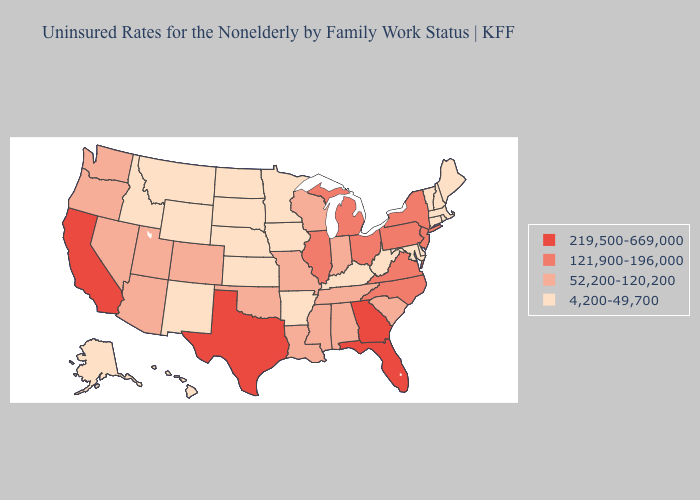Among the states that border Indiana , does Ohio have the highest value?
Give a very brief answer. Yes. Name the states that have a value in the range 4,200-49,700?
Concise answer only. Alaska, Arkansas, Connecticut, Delaware, Hawaii, Idaho, Iowa, Kansas, Kentucky, Maine, Maryland, Massachusetts, Minnesota, Montana, Nebraska, New Hampshire, New Mexico, North Dakota, Rhode Island, South Dakota, Vermont, West Virginia, Wyoming. Does Mississippi have the highest value in the South?
Be succinct. No. Which states have the lowest value in the South?
Answer briefly. Arkansas, Delaware, Kentucky, Maryland, West Virginia. Which states have the lowest value in the USA?
Short answer required. Alaska, Arkansas, Connecticut, Delaware, Hawaii, Idaho, Iowa, Kansas, Kentucky, Maine, Maryland, Massachusetts, Minnesota, Montana, Nebraska, New Hampshire, New Mexico, North Dakota, Rhode Island, South Dakota, Vermont, West Virginia, Wyoming. What is the value of Ohio?
Give a very brief answer. 121,900-196,000. What is the value of Washington?
Give a very brief answer. 52,200-120,200. Does the map have missing data?
Give a very brief answer. No. Name the states that have a value in the range 219,500-669,000?
Answer briefly. California, Florida, Georgia, Texas. What is the value of South Dakota?
Short answer required. 4,200-49,700. Does Maryland have the lowest value in the South?
Concise answer only. Yes. Does Rhode Island have the lowest value in the USA?
Quick response, please. Yes. Name the states that have a value in the range 52,200-120,200?
Write a very short answer. Alabama, Arizona, Colorado, Indiana, Louisiana, Mississippi, Missouri, Nevada, Oklahoma, Oregon, South Carolina, Tennessee, Utah, Washington, Wisconsin. What is the value of New Mexico?
Give a very brief answer. 4,200-49,700. What is the lowest value in the USA?
Concise answer only. 4,200-49,700. 